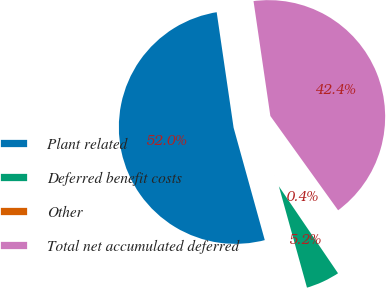<chart> <loc_0><loc_0><loc_500><loc_500><pie_chart><fcel>Plant related<fcel>Deferred benefit costs<fcel>Other<fcel>Total net accumulated deferred<nl><fcel>51.99%<fcel>5.2%<fcel>0.41%<fcel>42.4%<nl></chart> 